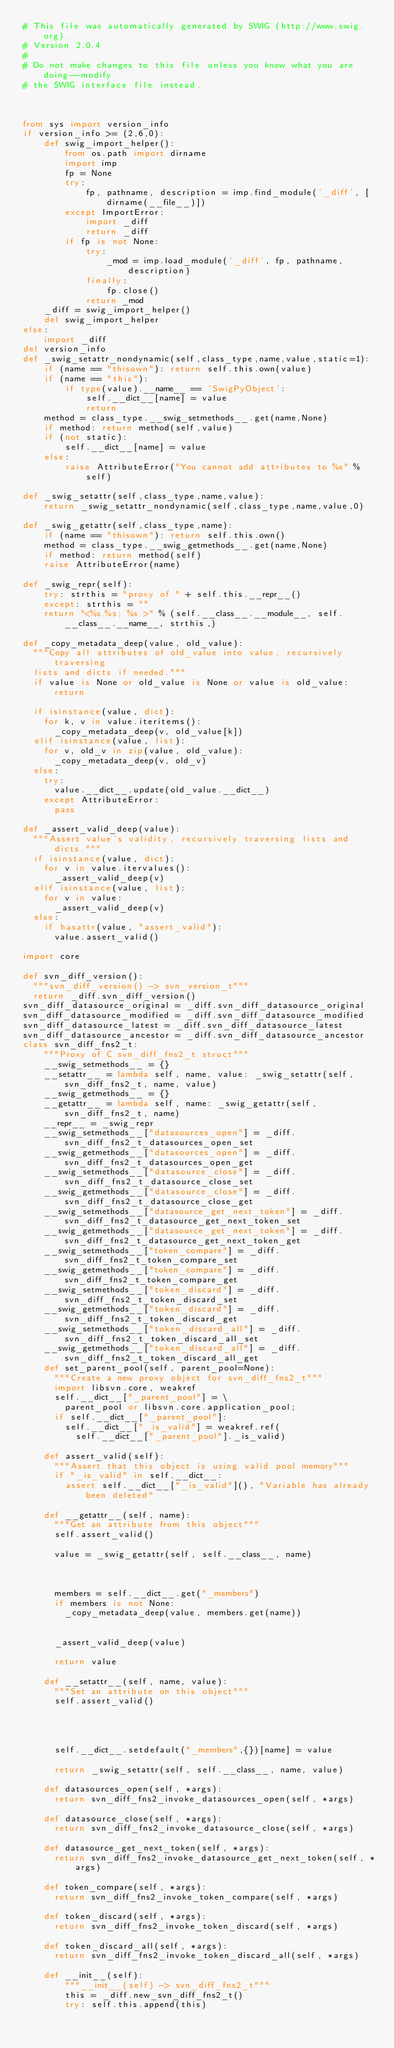<code> <loc_0><loc_0><loc_500><loc_500><_Python_># This file was automatically generated by SWIG (http://www.swig.org).
# Version 2.0.4
#
# Do not make changes to this file unless you know what you are doing--modify
# the SWIG interface file instead.



from sys import version_info
if version_info >= (2,6,0):
    def swig_import_helper():
        from os.path import dirname
        import imp
        fp = None
        try:
            fp, pathname, description = imp.find_module('_diff', [dirname(__file__)])
        except ImportError:
            import _diff
            return _diff
        if fp is not None:
            try:
                _mod = imp.load_module('_diff', fp, pathname, description)
            finally:
                fp.close()
            return _mod
    _diff = swig_import_helper()
    del swig_import_helper
else:
    import _diff
del version_info
def _swig_setattr_nondynamic(self,class_type,name,value,static=1):
    if (name == "thisown"): return self.this.own(value)
    if (name == "this"):
        if type(value).__name__ == 'SwigPyObject':
            self.__dict__[name] = value
            return
    method = class_type.__swig_setmethods__.get(name,None)
    if method: return method(self,value)
    if (not static):
        self.__dict__[name] = value
    else:
        raise AttributeError("You cannot add attributes to %s" % self)

def _swig_setattr(self,class_type,name,value):
    return _swig_setattr_nondynamic(self,class_type,name,value,0)

def _swig_getattr(self,class_type,name):
    if (name == "thisown"): return self.this.own()
    method = class_type.__swig_getmethods__.get(name,None)
    if method: return method(self)
    raise AttributeError(name)

def _swig_repr(self):
    try: strthis = "proxy of " + self.this.__repr__()
    except: strthis = ""
    return "<%s.%s; %s >" % (self.__class__.__module__, self.__class__.__name__, strthis,)

def _copy_metadata_deep(value, old_value):
  """Copy all attributes of old_value into value, recursively traversing
  lists and dicts if needed."""
  if value is None or old_value is None or value is old_value: return
  
  if isinstance(value, dict):
    for k, v in value.iteritems():
      _copy_metadata_deep(v, old_value[k])
  elif isinstance(value, list):
    for v, old_v in zip(value, old_value):
      _copy_metadata_deep(v, old_v)
  else:
    try:
      value.__dict__.update(old_value.__dict__)
    except AttributeError:
      pass
      
def _assert_valid_deep(value):
  """Assert value's validity, recursively traversing lists and dicts."""
  if isinstance(value, dict):
    for v in value.itervalues():
      _assert_valid_deep(v)
  elif isinstance(value, list):
    for v in value:
      _assert_valid_deep(v)
  else:
    if hasattr(value, "assert_valid"):
      value.assert_valid()

import core

def svn_diff_version():
  """svn_diff_version() -> svn_version_t"""
  return _diff.svn_diff_version()
svn_diff_datasource_original = _diff.svn_diff_datasource_original
svn_diff_datasource_modified = _diff.svn_diff_datasource_modified
svn_diff_datasource_latest = _diff.svn_diff_datasource_latest
svn_diff_datasource_ancestor = _diff.svn_diff_datasource_ancestor
class svn_diff_fns2_t:
    """Proxy of C svn_diff_fns2_t struct"""
    __swig_setmethods__ = {}
    __setattr__ = lambda self, name, value: _swig_setattr(self, svn_diff_fns2_t, name, value)
    __swig_getmethods__ = {}
    __getattr__ = lambda self, name: _swig_getattr(self, svn_diff_fns2_t, name)
    __repr__ = _swig_repr
    __swig_setmethods__["datasources_open"] = _diff.svn_diff_fns2_t_datasources_open_set
    __swig_getmethods__["datasources_open"] = _diff.svn_diff_fns2_t_datasources_open_get
    __swig_setmethods__["datasource_close"] = _diff.svn_diff_fns2_t_datasource_close_set
    __swig_getmethods__["datasource_close"] = _diff.svn_diff_fns2_t_datasource_close_get
    __swig_setmethods__["datasource_get_next_token"] = _diff.svn_diff_fns2_t_datasource_get_next_token_set
    __swig_getmethods__["datasource_get_next_token"] = _diff.svn_diff_fns2_t_datasource_get_next_token_get
    __swig_setmethods__["token_compare"] = _diff.svn_diff_fns2_t_token_compare_set
    __swig_getmethods__["token_compare"] = _diff.svn_diff_fns2_t_token_compare_get
    __swig_setmethods__["token_discard"] = _diff.svn_diff_fns2_t_token_discard_set
    __swig_getmethods__["token_discard"] = _diff.svn_diff_fns2_t_token_discard_get
    __swig_setmethods__["token_discard_all"] = _diff.svn_diff_fns2_t_token_discard_all_set
    __swig_getmethods__["token_discard_all"] = _diff.svn_diff_fns2_t_token_discard_all_get
    def set_parent_pool(self, parent_pool=None):
      """Create a new proxy object for svn_diff_fns2_t"""
      import libsvn.core, weakref
      self.__dict__["_parent_pool"] = \
        parent_pool or libsvn.core.application_pool;
      if self.__dict__["_parent_pool"]:
        self.__dict__["_is_valid"] = weakref.ref(
          self.__dict__["_parent_pool"]._is_valid)

    def assert_valid(self):
      """Assert that this object is using valid pool memory"""
      if "_is_valid" in self.__dict__:
        assert self.__dict__["_is_valid"](), "Variable has already been deleted"

    def __getattr__(self, name):
      """Get an attribute from this object"""
      self.assert_valid()

      value = _swig_getattr(self, self.__class__, name)



      members = self.__dict__.get("_members")
      if members is not None:
        _copy_metadata_deep(value, members.get(name))
          

      _assert_valid_deep(value)

      return value

    def __setattr__(self, name, value):
      """Set an attribute on this object"""
      self.assert_valid()




      self.__dict__.setdefault("_members",{})[name] = value

      return _swig_setattr(self, self.__class__, name, value)

    def datasources_open(self, *args):
      return svn_diff_fns2_invoke_datasources_open(self, *args)

    def datasource_close(self, *args):
      return svn_diff_fns2_invoke_datasource_close(self, *args)

    def datasource_get_next_token(self, *args):
      return svn_diff_fns2_invoke_datasource_get_next_token(self, *args)

    def token_compare(self, *args):
      return svn_diff_fns2_invoke_token_compare(self, *args)

    def token_discard(self, *args):
      return svn_diff_fns2_invoke_token_discard(self, *args)

    def token_discard_all(self, *args):
      return svn_diff_fns2_invoke_token_discard_all(self, *args)

    def __init__(self): 
        """__init__(self) -> svn_diff_fns2_t"""
        this = _diff.new_svn_diff_fns2_t()
        try: self.this.append(this)</code> 